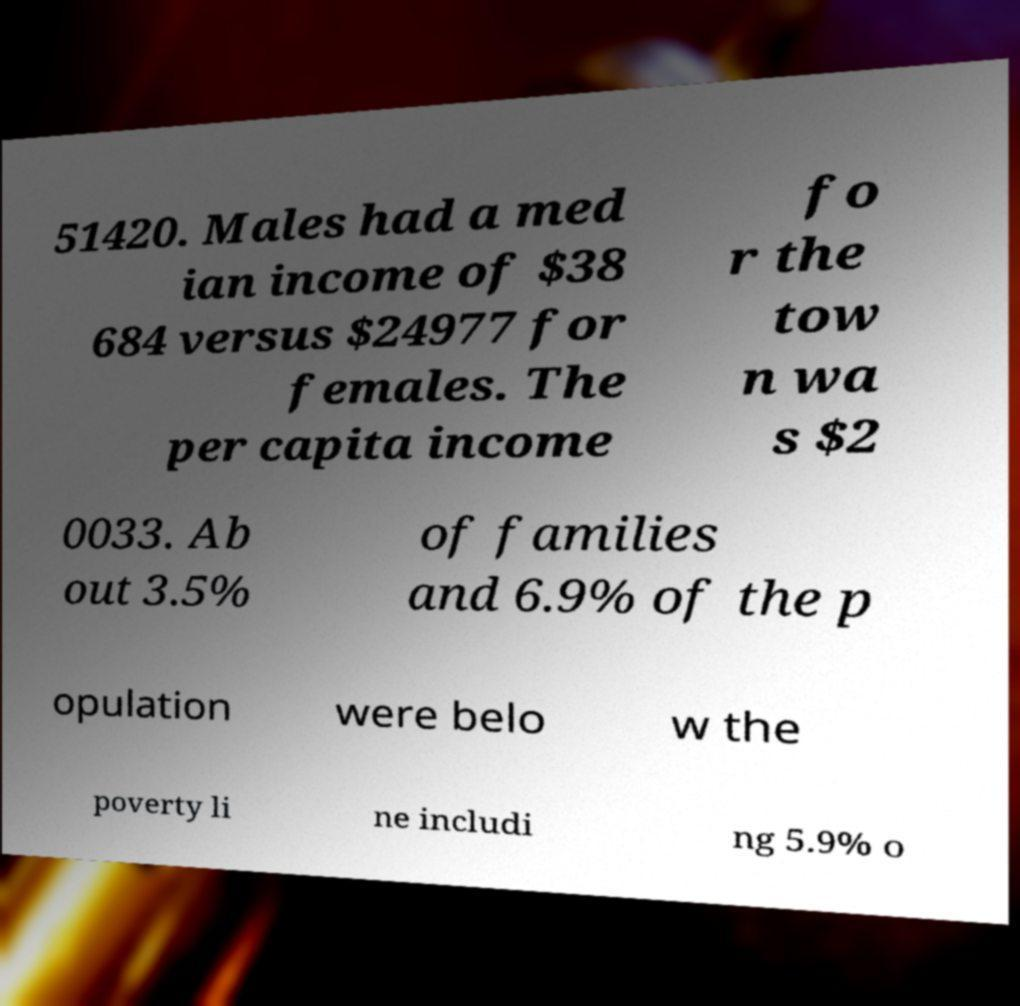Please identify and transcribe the text found in this image. 51420. Males had a med ian income of $38 684 versus $24977 for females. The per capita income fo r the tow n wa s $2 0033. Ab out 3.5% of families and 6.9% of the p opulation were belo w the poverty li ne includi ng 5.9% o 